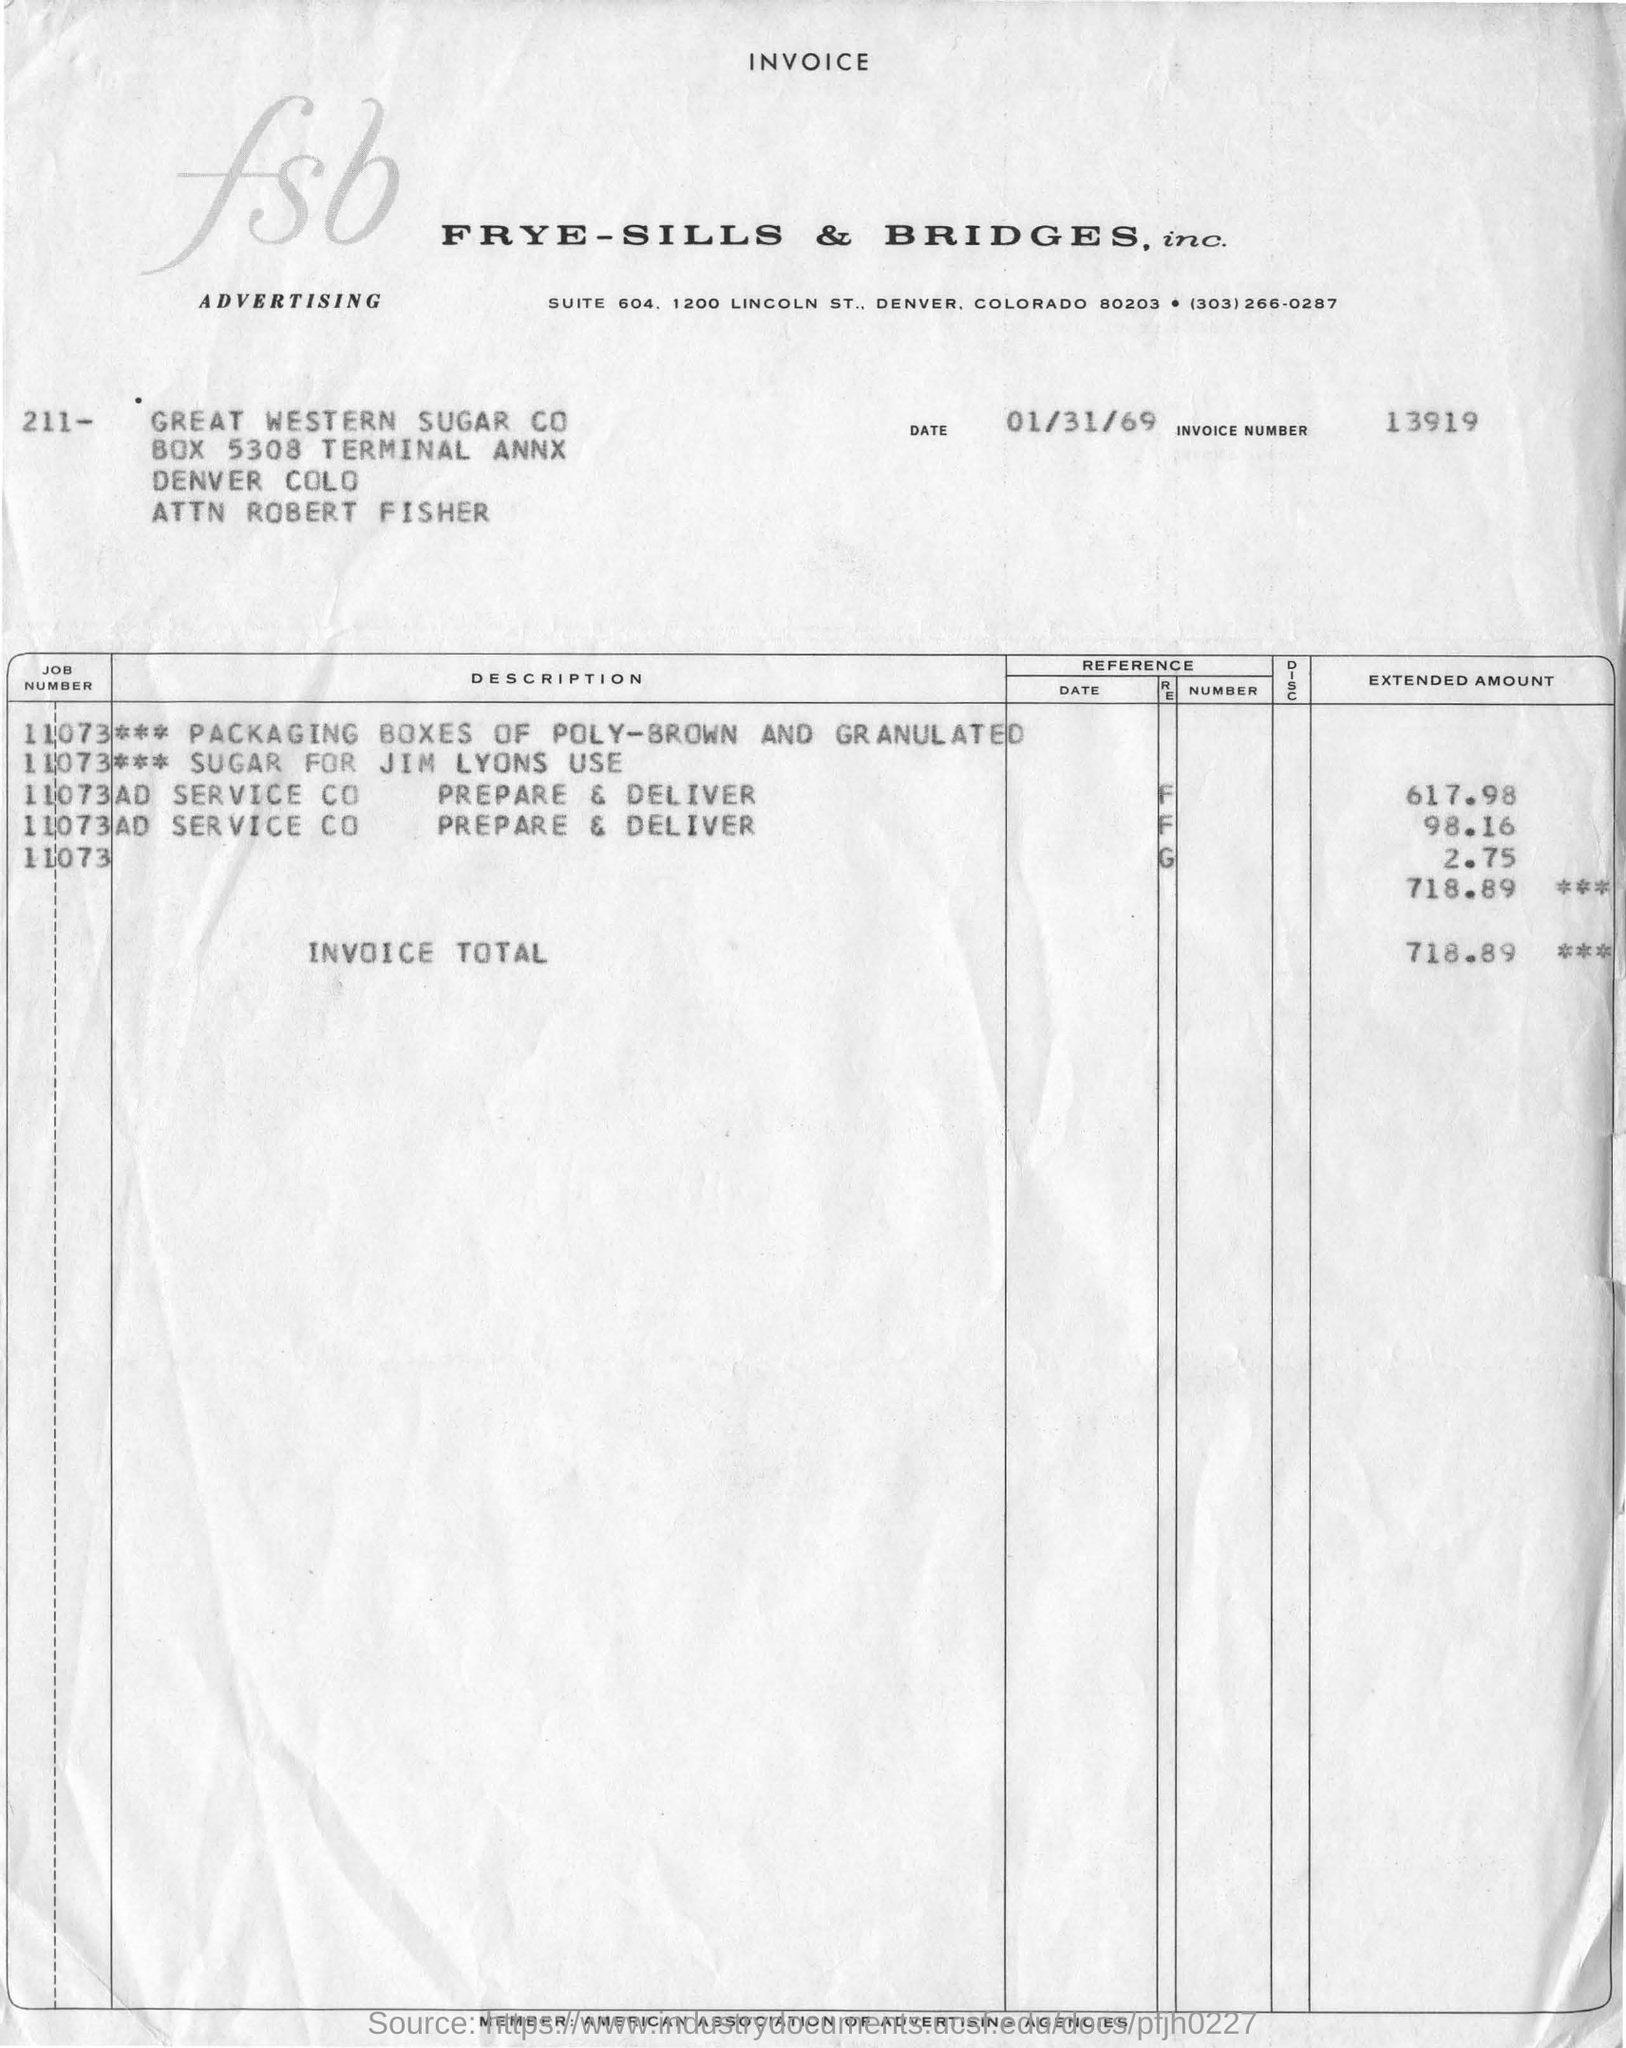For whom is the Invoice raised?
Give a very brief answer. Frye-Sills & Bridges, inc. What is the Invoice Number?
Your answer should be compact. 13919. What is the Total amount of the Invoice?
Ensure brevity in your answer.  718.89. What is the Invoice date?
Offer a terse response. 01/31/69. 